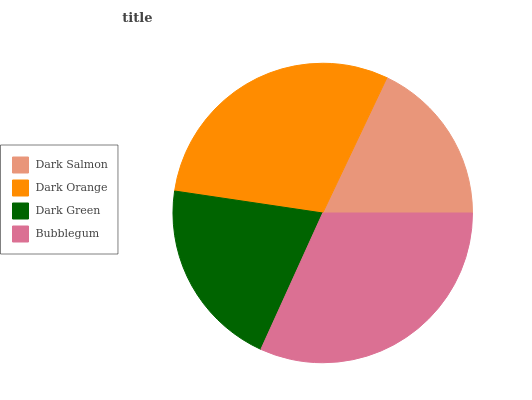Is Dark Salmon the minimum?
Answer yes or no. Yes. Is Bubblegum the maximum?
Answer yes or no. Yes. Is Dark Orange the minimum?
Answer yes or no. No. Is Dark Orange the maximum?
Answer yes or no. No. Is Dark Orange greater than Dark Salmon?
Answer yes or no. Yes. Is Dark Salmon less than Dark Orange?
Answer yes or no. Yes. Is Dark Salmon greater than Dark Orange?
Answer yes or no. No. Is Dark Orange less than Dark Salmon?
Answer yes or no. No. Is Dark Orange the high median?
Answer yes or no. Yes. Is Dark Green the low median?
Answer yes or no. Yes. Is Dark Green the high median?
Answer yes or no. No. Is Bubblegum the low median?
Answer yes or no. No. 